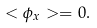Convert formula to latex. <formula><loc_0><loc_0><loc_500><loc_500>< \phi _ { x } > = 0 .</formula> 